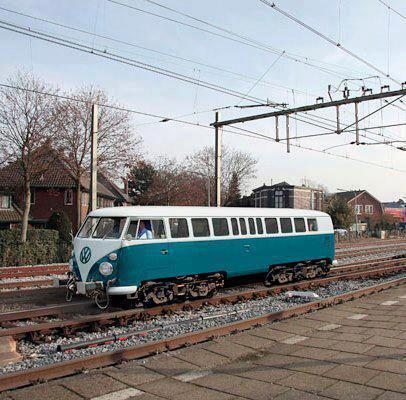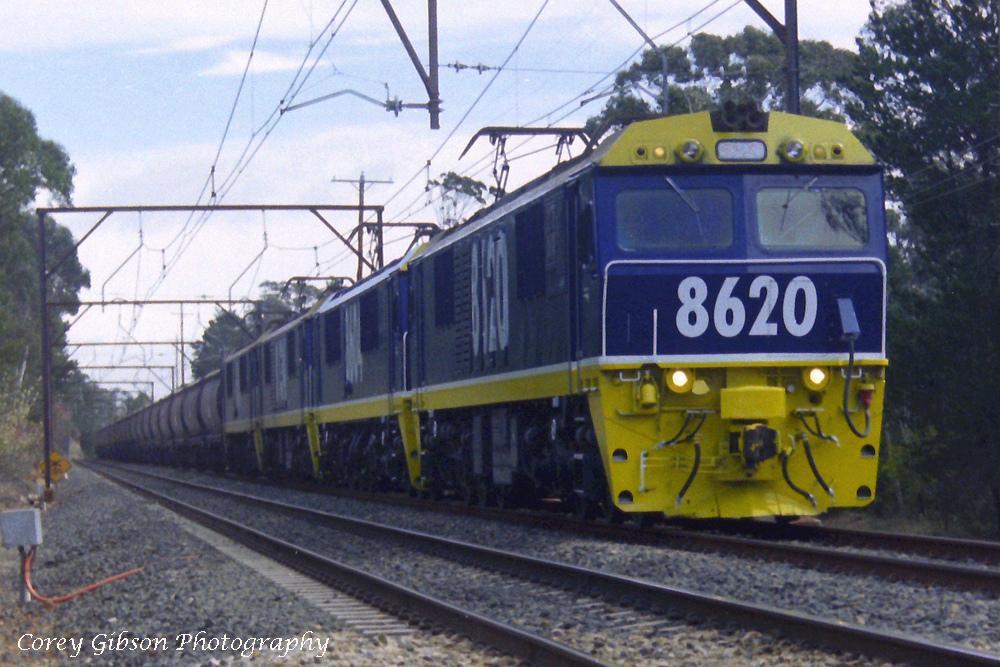The first image is the image on the left, the second image is the image on the right. Evaluate the accuracy of this statement regarding the images: "A train is on a track next to bare-branched trees and a house with a peaked roof in one image.". Is it true? Answer yes or no. Yes. The first image is the image on the left, the second image is the image on the right. Assess this claim about the two images: "The train in the image on the right has a single windshield.". Correct or not? Answer yes or no. No. 